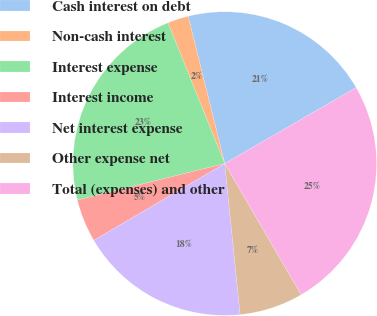Convert chart. <chart><loc_0><loc_0><loc_500><loc_500><pie_chart><fcel>Cash interest on debt<fcel>Non-cash interest<fcel>Interest expense<fcel>Interest income<fcel>Net interest expense<fcel>Other expense net<fcel>Total (expenses) and other<nl><fcel>20.53%<fcel>2.23%<fcel>22.76%<fcel>4.58%<fcel>18.18%<fcel>6.78%<fcel>24.95%<nl></chart> 